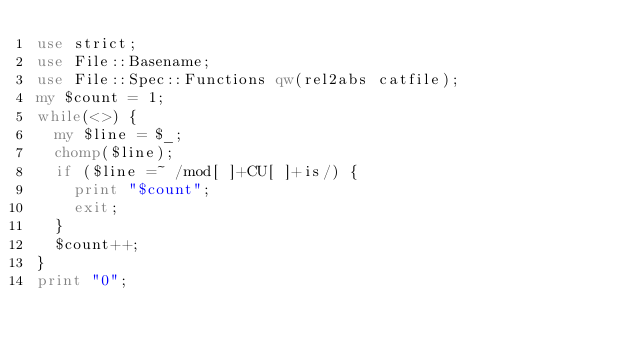<code> <loc_0><loc_0><loc_500><loc_500><_Perl_>use strict;
use File::Basename;
use File::Spec::Functions qw(rel2abs catfile);
my $count = 1;
while(<>) {
	my $line = $_;
	chomp($line);
	if ($line =~ /mod[ ]+CU[ ]+is/) {
		print "$count";
		exit;
	}
	$count++;
}
print "0";

</code> 